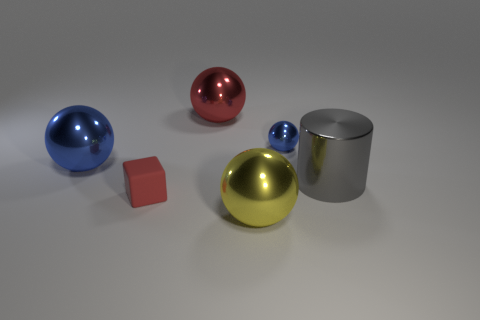Is the number of large gray metallic objects that are on the left side of the large gray cylinder less than the number of large red balls in front of the red metal object? Upon reviewing the image, it is observed that there is one large gray metallic cylinder and two large red balls. Therefore, the number of large gray metallic objects is indeed less than the number of large red balls. The earlier response of 'no' was inaccurate. 